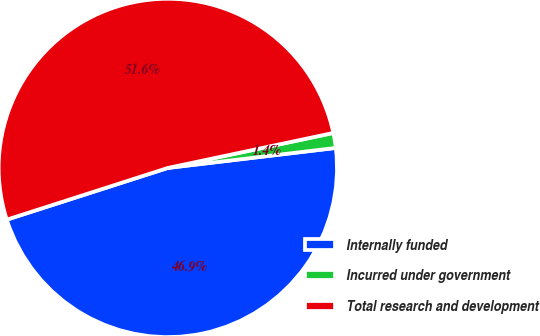<chart> <loc_0><loc_0><loc_500><loc_500><pie_chart><fcel>Internally funded<fcel>Incurred under government<fcel>Total research and development<nl><fcel>46.94%<fcel>1.43%<fcel>51.63%<nl></chart> 